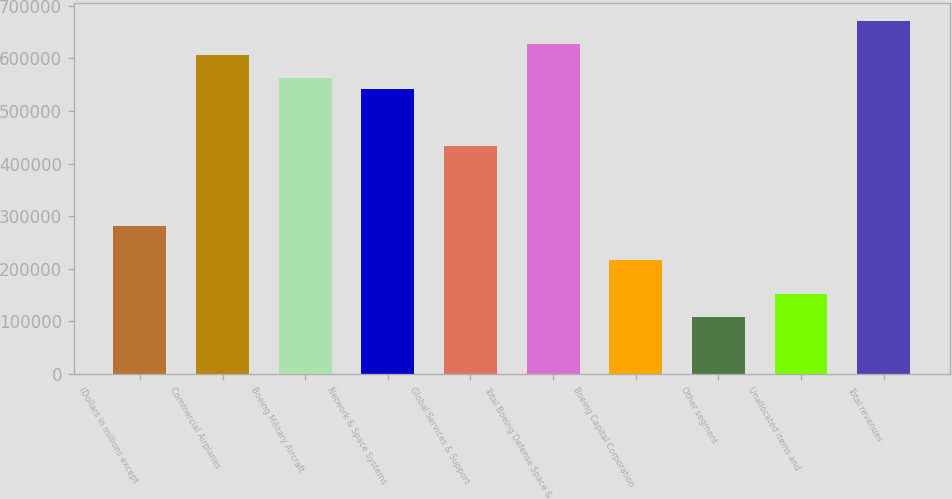Convert chart. <chart><loc_0><loc_0><loc_500><loc_500><bar_chart><fcel>(Dollars in millions except<fcel>Commercial Airplanes<fcel>Boeing Military Aircraft<fcel>Network & Space Systems<fcel>Global Services & Support<fcel>Total Boeing Defense Space &<fcel>Boeing Capital Corporation<fcel>Other segment<fcel>Unallocated items and<fcel>Total revenues<nl><fcel>281532<fcel>606374<fcel>563062<fcel>541406<fcel>433125<fcel>628030<fcel>216563<fcel>108282<fcel>151594<fcel>671343<nl></chart> 